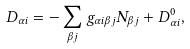<formula> <loc_0><loc_0><loc_500><loc_500>D _ { \alpha i } = - \sum _ { \beta j } g _ { \alpha i \beta j } N _ { \beta j } + D _ { \alpha i } ^ { 0 } ,</formula> 